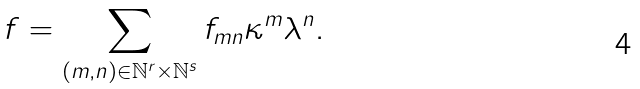Convert formula to latex. <formula><loc_0><loc_0><loc_500><loc_500>f = \sum _ { ( m , n ) \in \mathbb { N } ^ { r } \times \mathbb { N } ^ { s } } f _ { m n } \kappa ^ { m } \lambda ^ { n } .</formula> 